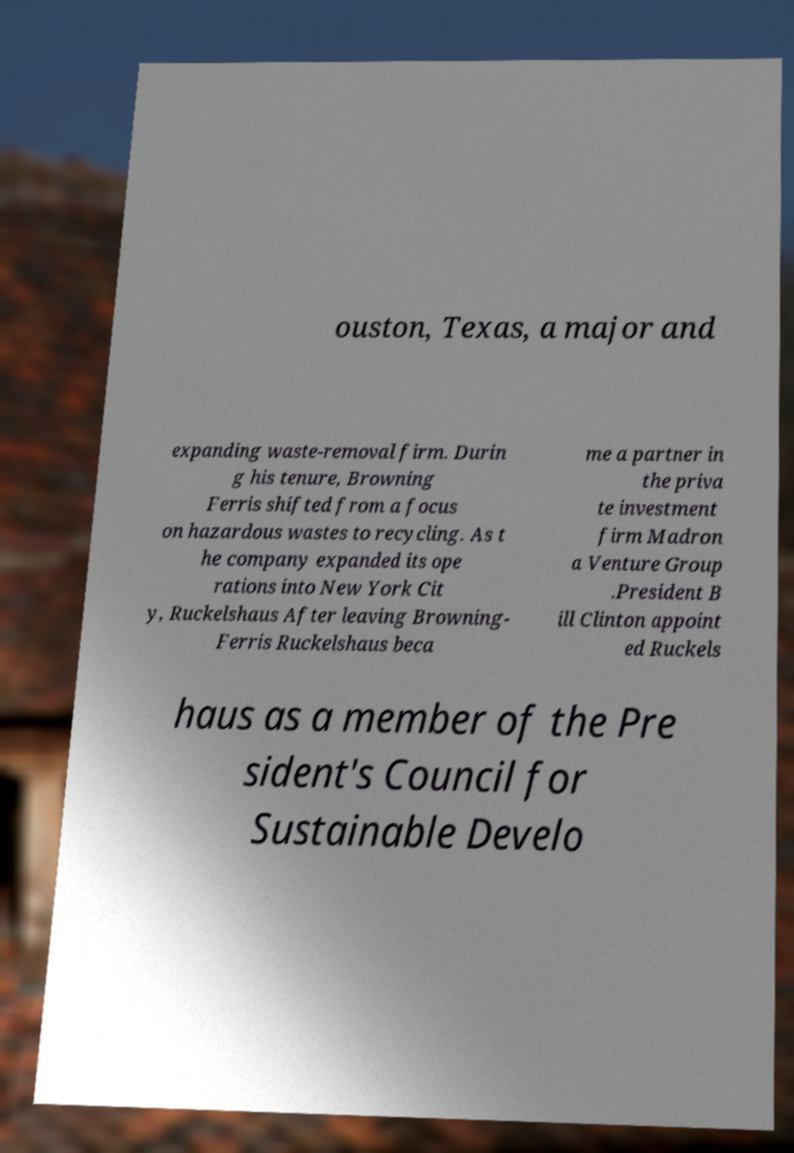Please identify and transcribe the text found in this image. ouston, Texas, a major and expanding waste-removal firm. Durin g his tenure, Browning Ferris shifted from a focus on hazardous wastes to recycling. As t he company expanded its ope rations into New York Cit y, Ruckelshaus After leaving Browning- Ferris Ruckelshaus beca me a partner in the priva te investment firm Madron a Venture Group .President B ill Clinton appoint ed Ruckels haus as a member of the Pre sident's Council for Sustainable Develo 